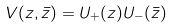<formula> <loc_0><loc_0><loc_500><loc_500>V ( z , \bar { z } ) = U _ { + } ( z ) U _ { - } ( \bar { z } )</formula> 